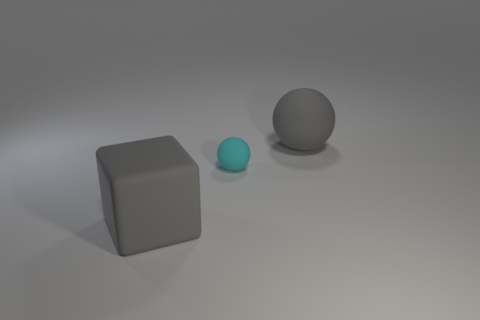Is there any other thing that is the same size as the cyan matte ball?
Your answer should be compact. No. Is the color of the big rubber thing left of the gray sphere the same as the big matte ball?
Your answer should be compact. Yes. There is a big gray thing right of the large block; is there a gray rubber thing in front of it?
Offer a terse response. Yes. Are there fewer blocks that are right of the small cyan ball than large gray blocks right of the cube?
Offer a terse response. No. There is a gray block in front of the large rubber thing on the right side of the big gray object that is to the left of the cyan matte sphere; how big is it?
Offer a very short reply. Large. Is the size of the sphere that is in front of the gray ball the same as the cube?
Your answer should be compact. No. What number of other things are there of the same material as the gray block
Make the answer very short. 2. Are there more gray matte blocks than purple metallic things?
Make the answer very short. Yes. Do the big matte block and the large ball have the same color?
Offer a terse response. Yes. Are there any big cubes that have the same color as the big matte ball?
Your response must be concise. Yes. 